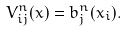Convert formula to latex. <formula><loc_0><loc_0><loc_500><loc_500>V ^ { n } _ { i j } ( x ) = b ^ { n } _ { j } ( x _ { i } ) .</formula> 